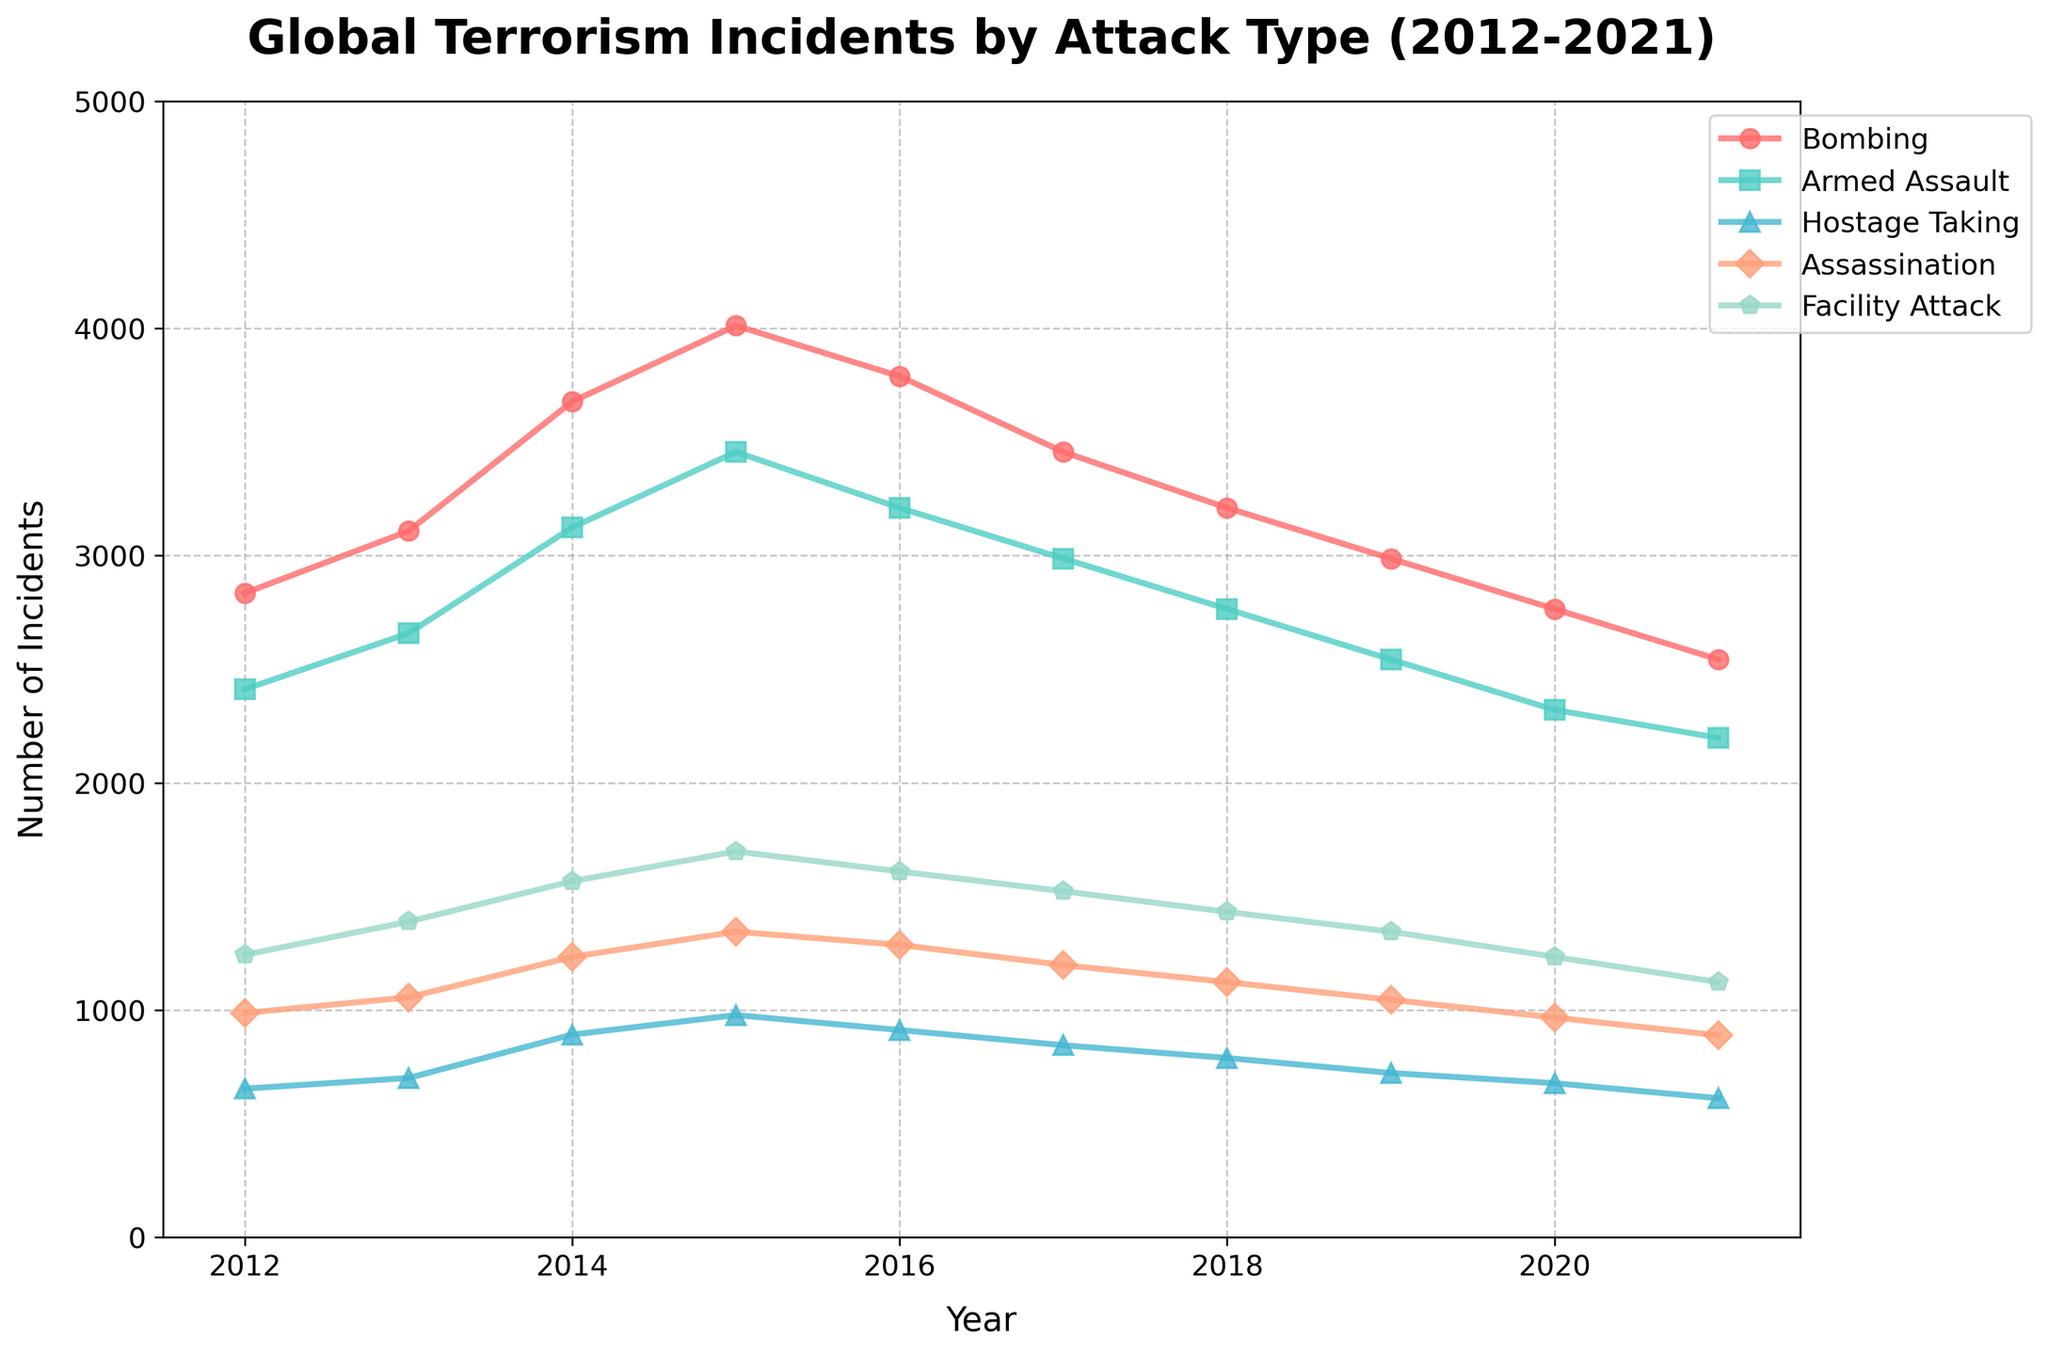How many years have Bombing incidents been higher than1 Facility Attack incidents? Count the number of years where the Bombing line (red) is above the Facility Attack line (green). This occurs in all years from 2012 to 2021.
Answer: 10 Which year experienced the highest number of Hostage Taking incidents and what is the value? Look at the peaks of the purple line that represents Hostage Taking incidents. The highest point is in 2015 with a value of 978 incidents.
Answer: 2015, 978 During which year did Armed Assault incidents first decline? Identify the trend in the teal line representing Armed Assault incidents. The first decline occurs from 2015 to 2016.
Answer: 2016 What is the total number of incidents across all attack types in 2014? Sum up the values for each attack type in 2014: Bombing (3678), Armed Assault (3124), Hostage Taking (892), Assassination (1234), Facility Attack (1567). 3678 + 3124 + 892 + 1234 + 1567 = 10495.
Answer: 10495 Which attack type showed a continuous decline from 2015 to 2021? Observe the trends of each line from 2015 to 2021. The blue line, which represents Armed Assault, continuously declines during this period.
Answer: Armed Assault What is the average number of Assassination incidents per year? Add up all the number of Assassination incidents over the years and divide by the number of years: (987 + 1056 + 1234 + 1345 + 1287 + 1198 + 1123 + 1045 + 967 + 889) / 10 = 1113.1
Answer: 1113.1 Compare the numbers of Bombing and Armed Assault incidents in 2017. Which one is higher and by how much? Look at the values for 2017: Bombing (3456) and Armed Assault (2987). Subtract Armed Assault from Bombing: 3456 - 2987.
Answer: Bombing, 469 Which attack type had the closest number of incidents to Assassination incidents in 2019? Compare the values for each attack type in 2019 to Assassination (1045). Bombing (2987), Armed Assault (2543), Hostage Taking (723), Facility Attack (1345). Facility Attack is the closest with 1345 incidents.
Answer: Facility Attack From the chart, in which year did Facility Attack incidents exceed 1500 for the first time? Find the first year where the green line representing Facility Attack incidents exceeds 1500. This is in 2014.
Answer: 2014 